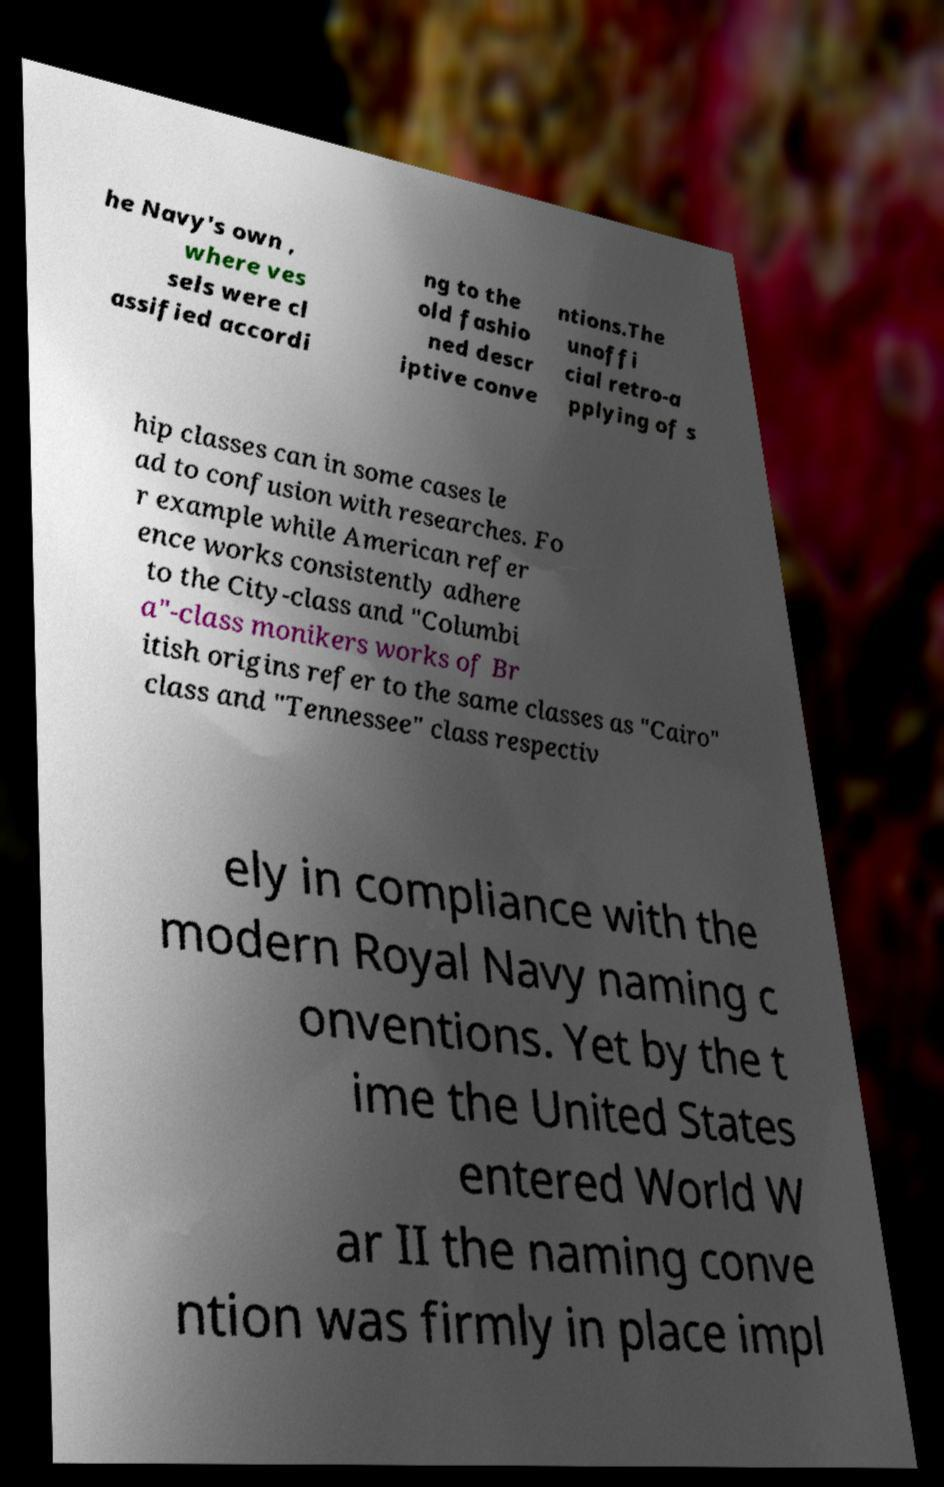Can you accurately transcribe the text from the provided image for me? he Navy's own , where ves sels were cl assified accordi ng to the old fashio ned descr iptive conve ntions.The unoffi cial retro-a pplying of s hip classes can in some cases le ad to confusion with researches. Fo r example while American refer ence works consistently adhere to the City-class and "Columbi a"-class monikers works of Br itish origins refer to the same classes as "Cairo" class and "Tennessee" class respectiv ely in compliance with the modern Royal Navy naming c onventions. Yet by the t ime the United States entered World W ar II the naming conve ntion was firmly in place impl 